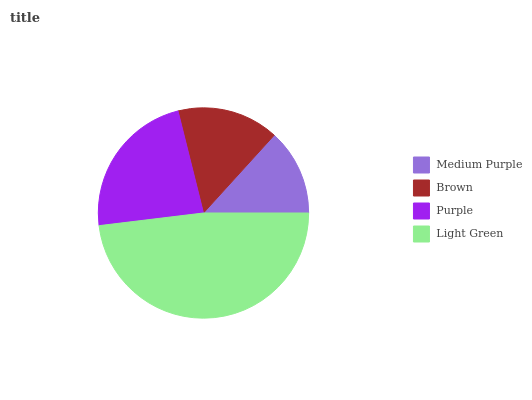Is Medium Purple the minimum?
Answer yes or no. Yes. Is Light Green the maximum?
Answer yes or no. Yes. Is Brown the minimum?
Answer yes or no. No. Is Brown the maximum?
Answer yes or no. No. Is Brown greater than Medium Purple?
Answer yes or no. Yes. Is Medium Purple less than Brown?
Answer yes or no. Yes. Is Medium Purple greater than Brown?
Answer yes or no. No. Is Brown less than Medium Purple?
Answer yes or no. No. Is Purple the high median?
Answer yes or no. Yes. Is Brown the low median?
Answer yes or no. Yes. Is Medium Purple the high median?
Answer yes or no. No. Is Light Green the low median?
Answer yes or no. No. 